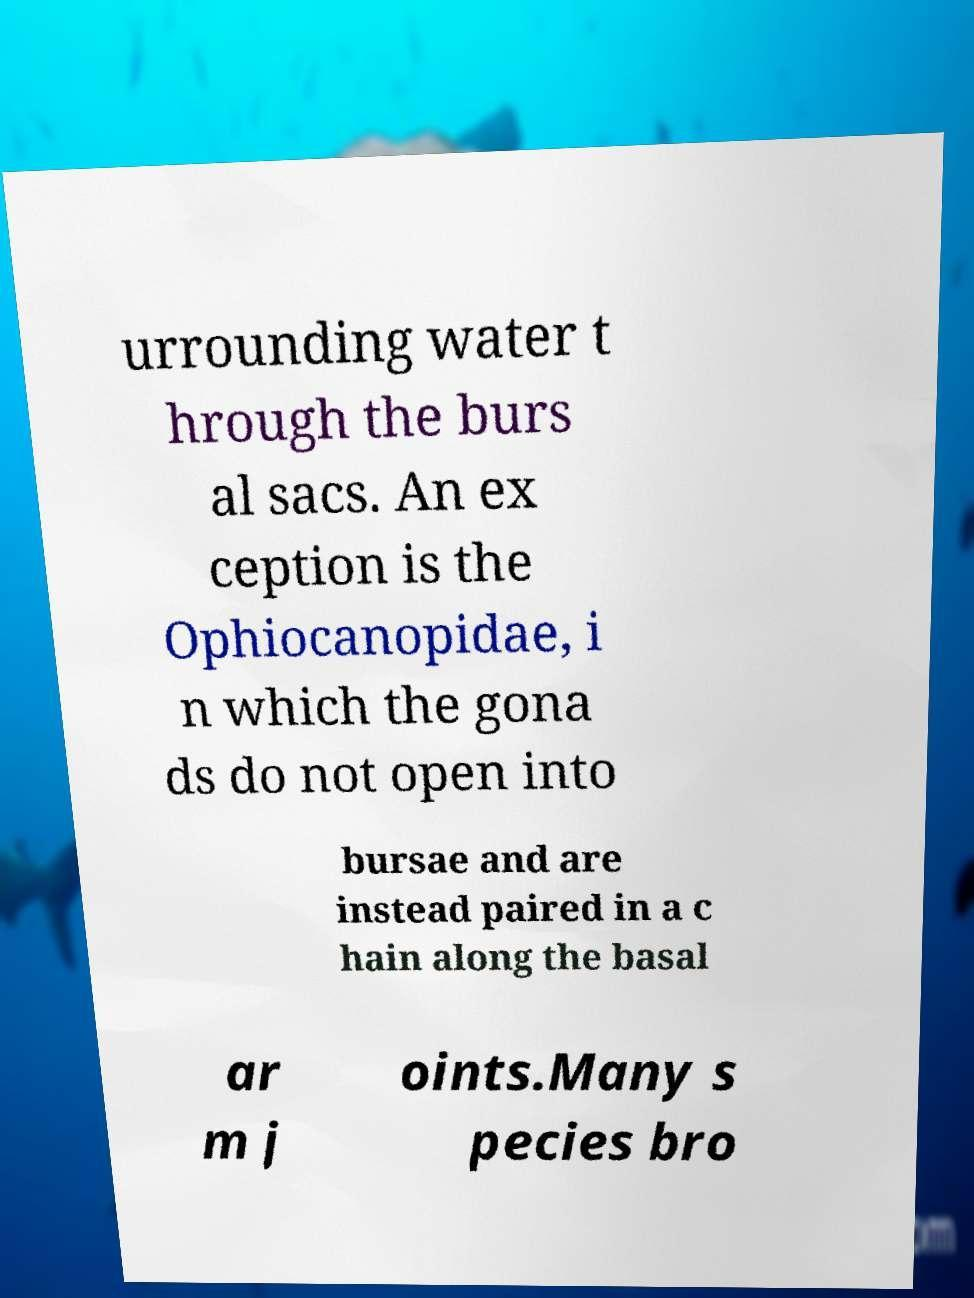What messages or text are displayed in this image? I need them in a readable, typed format. urrounding water t hrough the burs al sacs. An ex ception is the Ophiocanopidae, i n which the gona ds do not open into bursae and are instead paired in a c hain along the basal ar m j oints.Many s pecies bro 